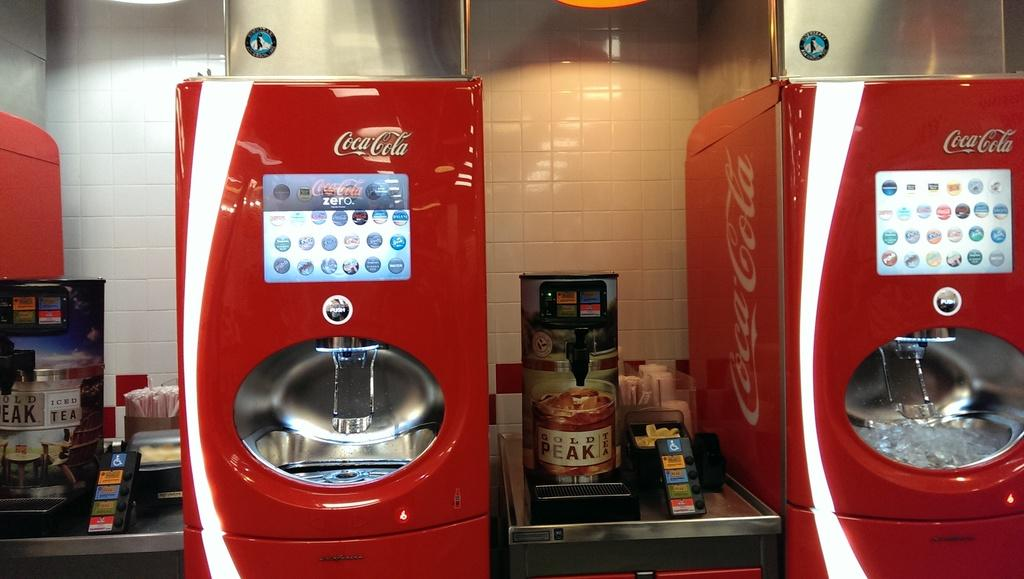<image>
Relay a brief, clear account of the picture shown. Two Coca Cola vending machines and also two dispensers of Gold Peak Tea. 